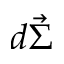Convert formula to latex. <formula><loc_0><loc_0><loc_500><loc_500>d \vec { \Sigma }</formula> 